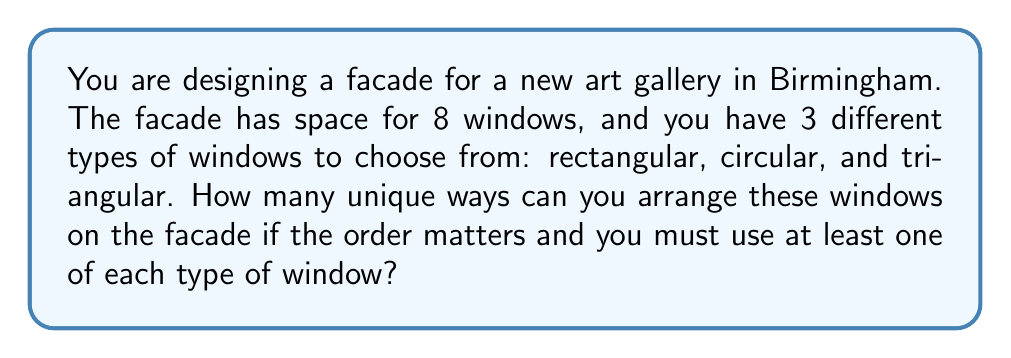Teach me how to tackle this problem. Let's approach this step-by-step:

1) First, we need to understand that we must use at least one of each type of window. This means we have 3 windows fixed (one of each type), and 5 windows that can be any of the three types.

2) We can think of this as filling 8 positions, where the first 3 positions are filled with the required windows (in any order), and the remaining 5 can be filled with any window type.

3) For the first 3 positions (the required windows):
   - We have 3! = 6 ways to arrange these 3 different windows.

4) For the remaining 5 positions:
   - Each position can be filled by any of the 3 types of windows.
   - This gives us 3 choices for each of the 5 positions.
   - The total number of ways to fill these 5 positions is thus $3^5$.

5) By the multiplication principle, the total number of arrangements is:
   $$ 3! \times 3^5 $$

6) Let's calculate this:
   $$ 6 \times 3^5 = 6 \times 243 = 1,458 $$

Therefore, there are 1,458 unique ways to arrange the windows on the facade.
Answer: 1,458 